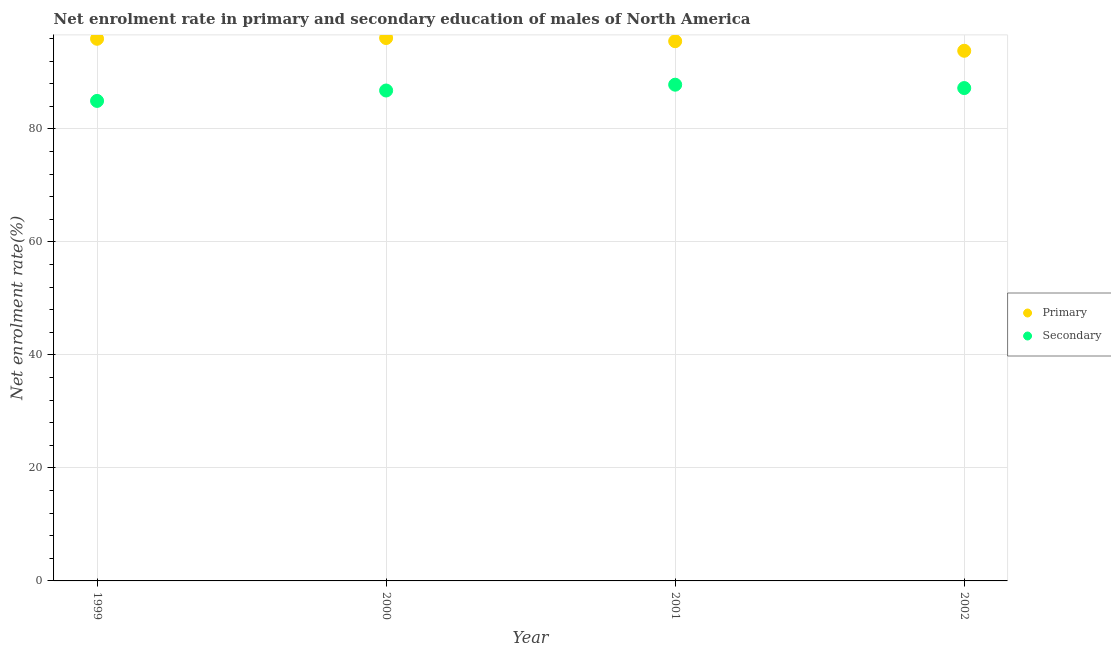How many different coloured dotlines are there?
Offer a very short reply. 2. Is the number of dotlines equal to the number of legend labels?
Offer a very short reply. Yes. What is the enrollment rate in secondary education in 2001?
Your response must be concise. 87.82. Across all years, what is the maximum enrollment rate in primary education?
Your response must be concise. 96.08. Across all years, what is the minimum enrollment rate in secondary education?
Your answer should be compact. 84.95. In which year was the enrollment rate in secondary education minimum?
Ensure brevity in your answer.  1999. What is the total enrollment rate in secondary education in the graph?
Make the answer very short. 346.77. What is the difference between the enrollment rate in primary education in 1999 and that in 2001?
Give a very brief answer. 0.43. What is the difference between the enrollment rate in primary education in 2001 and the enrollment rate in secondary education in 2000?
Make the answer very short. 8.73. What is the average enrollment rate in secondary education per year?
Provide a short and direct response. 86.69. In the year 2002, what is the difference between the enrollment rate in primary education and enrollment rate in secondary education?
Provide a succinct answer. 6.6. What is the ratio of the enrollment rate in secondary education in 2001 to that in 2002?
Offer a terse response. 1.01. What is the difference between the highest and the second highest enrollment rate in primary education?
Offer a terse response. 0.13. What is the difference between the highest and the lowest enrollment rate in primary education?
Your answer should be compact. 2.26. In how many years, is the enrollment rate in secondary education greater than the average enrollment rate in secondary education taken over all years?
Offer a very short reply. 3. Is the sum of the enrollment rate in secondary education in 2000 and 2001 greater than the maximum enrollment rate in primary education across all years?
Ensure brevity in your answer.  Yes. Is the enrollment rate in secondary education strictly greater than the enrollment rate in primary education over the years?
Make the answer very short. No. How many dotlines are there?
Your answer should be compact. 2. How many years are there in the graph?
Your response must be concise. 4. What is the difference between two consecutive major ticks on the Y-axis?
Keep it short and to the point. 20. Does the graph contain grids?
Provide a succinct answer. Yes. How are the legend labels stacked?
Your response must be concise. Vertical. What is the title of the graph?
Your answer should be compact. Net enrolment rate in primary and secondary education of males of North America. What is the label or title of the X-axis?
Your response must be concise. Year. What is the label or title of the Y-axis?
Ensure brevity in your answer.  Net enrolment rate(%). What is the Net enrolment rate(%) in Primary in 1999?
Your answer should be compact. 95.94. What is the Net enrolment rate(%) in Secondary in 1999?
Offer a terse response. 84.95. What is the Net enrolment rate(%) in Primary in 2000?
Offer a terse response. 96.08. What is the Net enrolment rate(%) of Secondary in 2000?
Offer a very short reply. 86.79. What is the Net enrolment rate(%) in Primary in 2001?
Provide a short and direct response. 95.51. What is the Net enrolment rate(%) in Secondary in 2001?
Ensure brevity in your answer.  87.82. What is the Net enrolment rate(%) in Primary in 2002?
Your response must be concise. 93.82. What is the Net enrolment rate(%) of Secondary in 2002?
Offer a terse response. 87.22. Across all years, what is the maximum Net enrolment rate(%) in Primary?
Keep it short and to the point. 96.08. Across all years, what is the maximum Net enrolment rate(%) in Secondary?
Provide a short and direct response. 87.82. Across all years, what is the minimum Net enrolment rate(%) of Primary?
Your answer should be compact. 93.82. Across all years, what is the minimum Net enrolment rate(%) of Secondary?
Provide a short and direct response. 84.95. What is the total Net enrolment rate(%) in Primary in the graph?
Provide a short and direct response. 381.35. What is the total Net enrolment rate(%) in Secondary in the graph?
Your answer should be compact. 346.77. What is the difference between the Net enrolment rate(%) in Primary in 1999 and that in 2000?
Your response must be concise. -0.13. What is the difference between the Net enrolment rate(%) in Secondary in 1999 and that in 2000?
Make the answer very short. -1.84. What is the difference between the Net enrolment rate(%) in Primary in 1999 and that in 2001?
Your answer should be compact. 0.43. What is the difference between the Net enrolment rate(%) of Secondary in 1999 and that in 2001?
Make the answer very short. -2.87. What is the difference between the Net enrolment rate(%) in Primary in 1999 and that in 2002?
Provide a succinct answer. 2.12. What is the difference between the Net enrolment rate(%) of Secondary in 1999 and that in 2002?
Keep it short and to the point. -2.27. What is the difference between the Net enrolment rate(%) of Primary in 2000 and that in 2001?
Give a very brief answer. 0.56. What is the difference between the Net enrolment rate(%) of Secondary in 2000 and that in 2001?
Give a very brief answer. -1.03. What is the difference between the Net enrolment rate(%) of Primary in 2000 and that in 2002?
Provide a short and direct response. 2.26. What is the difference between the Net enrolment rate(%) of Secondary in 2000 and that in 2002?
Keep it short and to the point. -0.43. What is the difference between the Net enrolment rate(%) in Primary in 2001 and that in 2002?
Offer a very short reply. 1.69. What is the difference between the Net enrolment rate(%) of Secondary in 2001 and that in 2002?
Keep it short and to the point. 0.6. What is the difference between the Net enrolment rate(%) in Primary in 1999 and the Net enrolment rate(%) in Secondary in 2000?
Your answer should be very brief. 9.15. What is the difference between the Net enrolment rate(%) in Primary in 1999 and the Net enrolment rate(%) in Secondary in 2001?
Make the answer very short. 8.13. What is the difference between the Net enrolment rate(%) in Primary in 1999 and the Net enrolment rate(%) in Secondary in 2002?
Offer a very short reply. 8.72. What is the difference between the Net enrolment rate(%) in Primary in 2000 and the Net enrolment rate(%) in Secondary in 2001?
Give a very brief answer. 8.26. What is the difference between the Net enrolment rate(%) of Primary in 2000 and the Net enrolment rate(%) of Secondary in 2002?
Your answer should be compact. 8.86. What is the difference between the Net enrolment rate(%) in Primary in 2001 and the Net enrolment rate(%) in Secondary in 2002?
Make the answer very short. 8.29. What is the average Net enrolment rate(%) in Primary per year?
Your answer should be very brief. 95.34. What is the average Net enrolment rate(%) of Secondary per year?
Offer a very short reply. 86.69. In the year 1999, what is the difference between the Net enrolment rate(%) of Primary and Net enrolment rate(%) of Secondary?
Your answer should be very brief. 11. In the year 2000, what is the difference between the Net enrolment rate(%) in Primary and Net enrolment rate(%) in Secondary?
Your answer should be compact. 9.29. In the year 2001, what is the difference between the Net enrolment rate(%) of Primary and Net enrolment rate(%) of Secondary?
Offer a very short reply. 7.7. In the year 2002, what is the difference between the Net enrolment rate(%) of Primary and Net enrolment rate(%) of Secondary?
Keep it short and to the point. 6.6. What is the ratio of the Net enrolment rate(%) in Secondary in 1999 to that in 2000?
Offer a very short reply. 0.98. What is the ratio of the Net enrolment rate(%) in Primary in 1999 to that in 2001?
Provide a short and direct response. 1. What is the ratio of the Net enrolment rate(%) in Secondary in 1999 to that in 2001?
Your answer should be compact. 0.97. What is the ratio of the Net enrolment rate(%) in Primary in 1999 to that in 2002?
Offer a terse response. 1.02. What is the ratio of the Net enrolment rate(%) in Secondary in 1999 to that in 2002?
Keep it short and to the point. 0.97. What is the ratio of the Net enrolment rate(%) in Primary in 2000 to that in 2001?
Offer a terse response. 1.01. What is the ratio of the Net enrolment rate(%) in Secondary in 2000 to that in 2001?
Your answer should be compact. 0.99. What is the ratio of the Net enrolment rate(%) of Primary in 2000 to that in 2002?
Offer a terse response. 1.02. What is the ratio of the Net enrolment rate(%) in Primary in 2001 to that in 2002?
Keep it short and to the point. 1.02. What is the ratio of the Net enrolment rate(%) in Secondary in 2001 to that in 2002?
Provide a succinct answer. 1.01. What is the difference between the highest and the second highest Net enrolment rate(%) of Primary?
Your response must be concise. 0.13. What is the difference between the highest and the second highest Net enrolment rate(%) of Secondary?
Provide a short and direct response. 0.6. What is the difference between the highest and the lowest Net enrolment rate(%) of Primary?
Your response must be concise. 2.26. What is the difference between the highest and the lowest Net enrolment rate(%) in Secondary?
Provide a succinct answer. 2.87. 